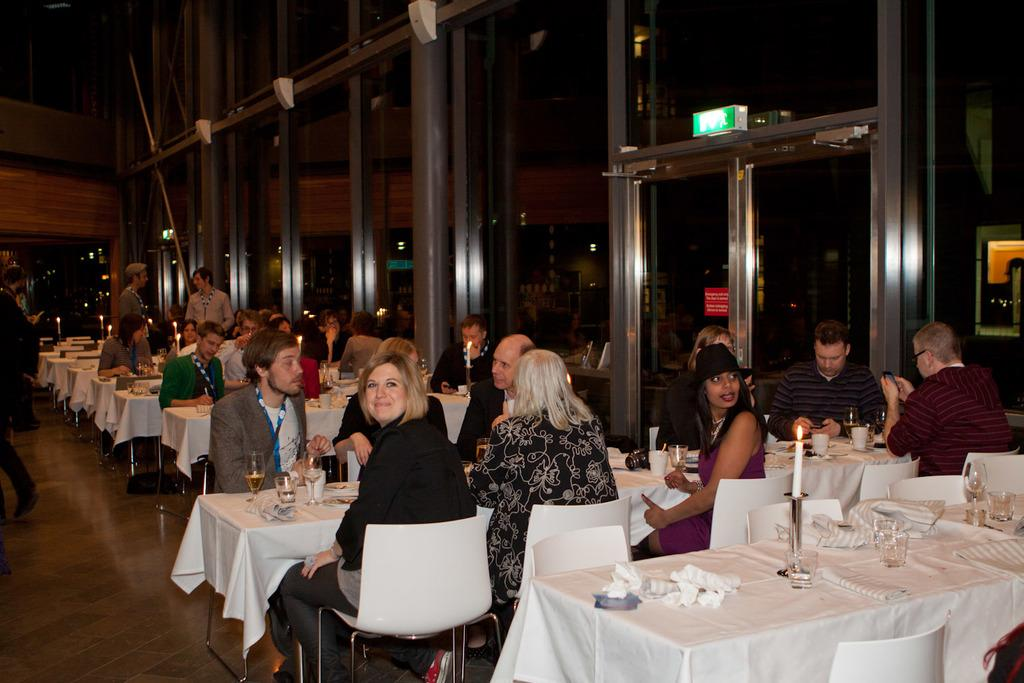Where was the image taken? The image was taken in a restaurant. What can be seen on the tables in the image? People are sitting at white tables, and food and eatables are placed on the tables. What is visible in the background of the image? There is a glass door and windows in the background. Can you see a tiger walking around in the restaurant in the image? No, there is no tiger present in the image. What type of iron is being used by the farmer in the image? There is no farmer or iron present in the image; it is a scene in a restaurant. 